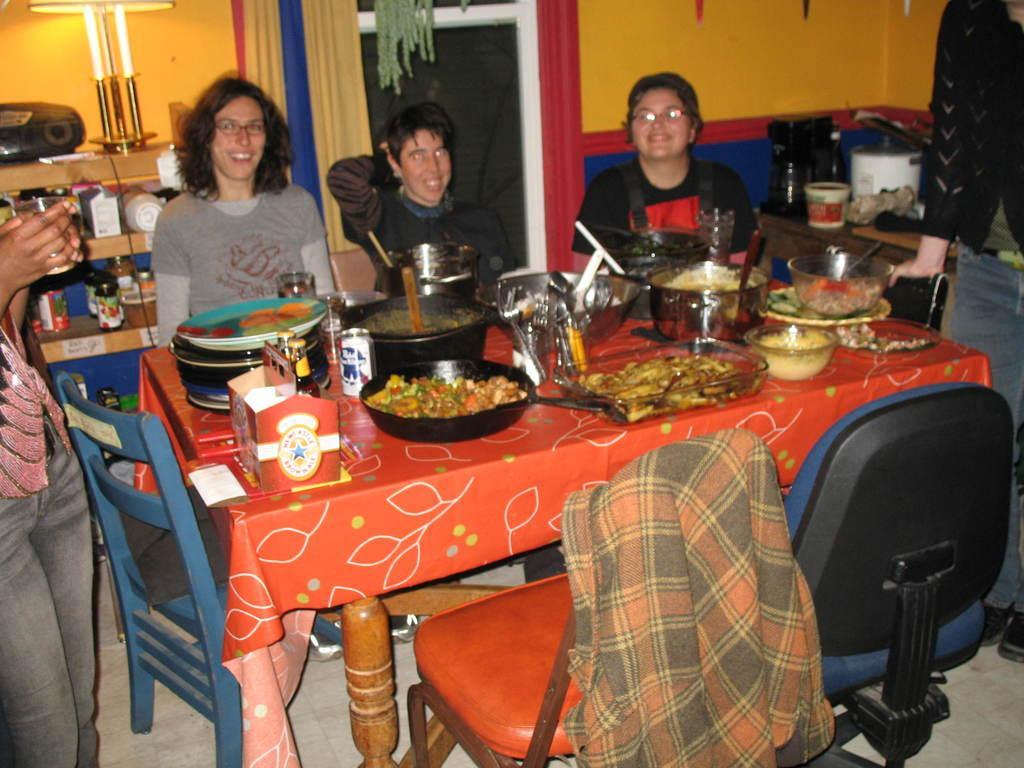In one or two sentences, can you explain what this image depicts? In this image, few peoples are sat on the chair. On left side, A human is standing. And there is a glass in his hand. We can see red color table, few items are placed on it. And some chairs at the bottom. Right side, a human is standing. there is a wooden table, few items are placed. At background, there is a door, curtain, wall. Left side, shelf, few items are placed. 